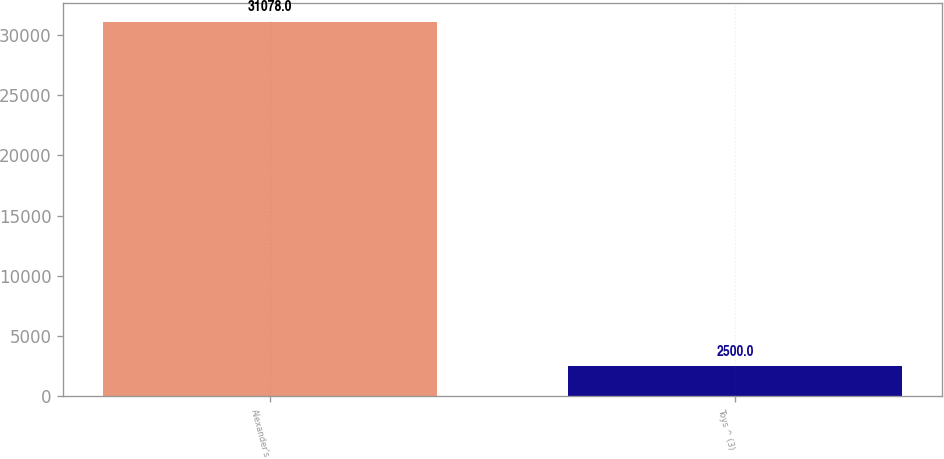Convert chart. <chart><loc_0><loc_0><loc_500><loc_500><bar_chart><fcel>Alexander's<fcel>Toys ^ (3)<nl><fcel>31078<fcel>2500<nl></chart> 